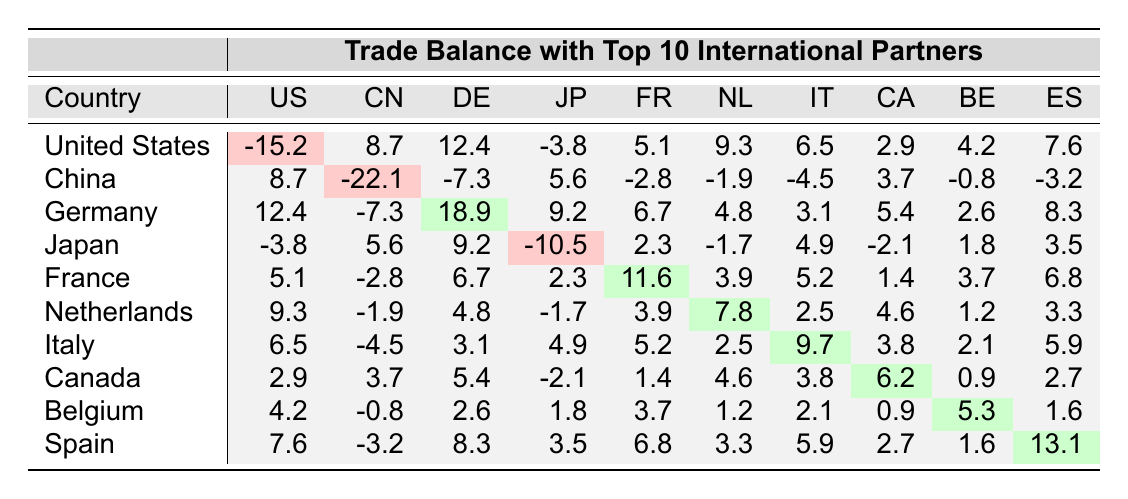What is the trade balance of the United States with China? In the table, we look at the row for the United States and find the corresponding column for China. The trade balance value is -15.2.
Answer: -15.2 Which country has the highest trade balance in the table? The table shows that Germany has the highest positive trade balance of 18.9 in the corresponding cell.
Answer: Germany What is the trade balance of Japan with Germany? By locating the row for Japan and the corresponding column for Germany, we see the trade balance value is 9.2.
Answer: 9.2 Is the trade balance with Canada positive? Looking at the row for Canada, the trade balance value is 6.2, which is positive.
Answer: Yes What is the sum of the trade balances of the United States and Japan with Spain? The trade balance of the United States with Spain is 7.6, and for Japan, it is 3.5. Summing these values: 7.6 + 3.5 = 11.1.
Answer: 11.1 Which country has a negative trade balance with both China and Japan? We examine the trade balances for China and Japan. China has a negative balance of -22.1 and Japan has -10.5, suggesting that both have negative balances with them. Confirming, we see that the United States and Japan both have negative balances with China and Japan respectively.
Answer: United States What is the average trade balance of the top three countries: Germany, France, and Netherlands? The trade balances are 18.9 for Germany, 11.6 for France, and 7.8 for the Netherlands. Adding these gives: 18.9 + 11.6 + 7.8 = 38.3. The average is 38.3/3 = 12.77.
Answer: 12.77 How does the trade balance with Belgium compare to that with France? The trade balance with Belgium is 5.3, while with France it is 11.6. To compare these, 5.3 is less than 11.6, indicating that the balance with Belgium is lower.
Answer: Lower What is the total of the trade balances for Germany with all other countries listed? We sum Germany's trade balances with the other countries: -7.3 (China), 9.2 (Japan), 6.7 (France), 4.8 (Netherlands), 3.1 (Italy), 5.4 (Canada), 2.6 (Belgium), and 8.3 (Spain): The total = 27.7.
Answer: 27.7 Is the trade balance of Italy with Canada higher than that of the Netherlands with Japan? Italy's balance with Canada is 3.8, while the Netherlands' with Japan is -1.7. Comparing these values shows that 3.8 is indeed higher than -1.7.
Answer: Yes What is the difference between the trade balances of China and Germany? China's trade balance is -22.1, and Germany's is 18.9. The difference is calculated as -22.1 - 18.9 = -41.0.
Answer: -41.0 